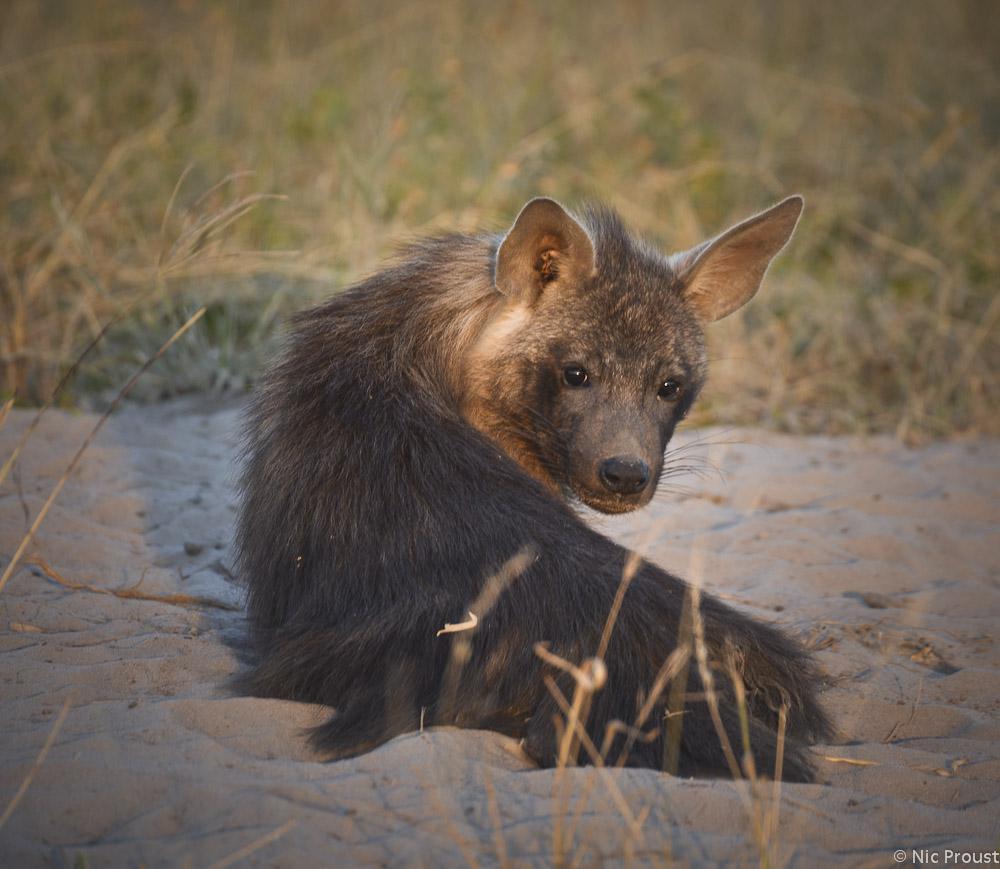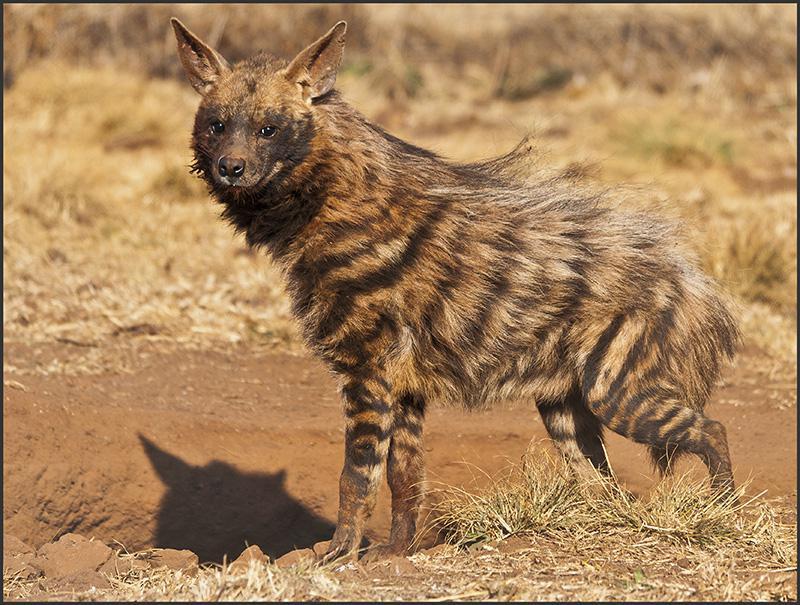The first image is the image on the left, the second image is the image on the right. Examine the images to the left and right. Is the description "There is a hyena standing in water." accurate? Answer yes or no. No. 